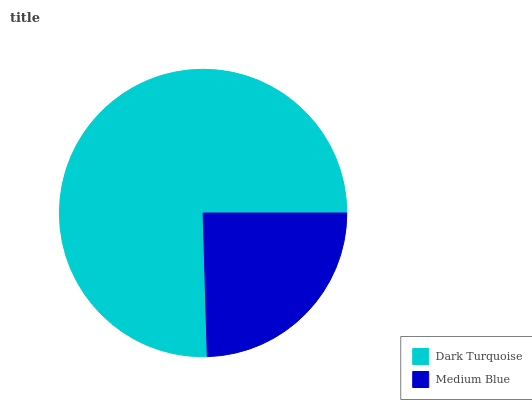Is Medium Blue the minimum?
Answer yes or no. Yes. Is Dark Turquoise the maximum?
Answer yes or no. Yes. Is Medium Blue the maximum?
Answer yes or no. No. Is Dark Turquoise greater than Medium Blue?
Answer yes or no. Yes. Is Medium Blue less than Dark Turquoise?
Answer yes or no. Yes. Is Medium Blue greater than Dark Turquoise?
Answer yes or no. No. Is Dark Turquoise less than Medium Blue?
Answer yes or no. No. Is Dark Turquoise the high median?
Answer yes or no. Yes. Is Medium Blue the low median?
Answer yes or no. Yes. Is Medium Blue the high median?
Answer yes or no. No. Is Dark Turquoise the low median?
Answer yes or no. No. 